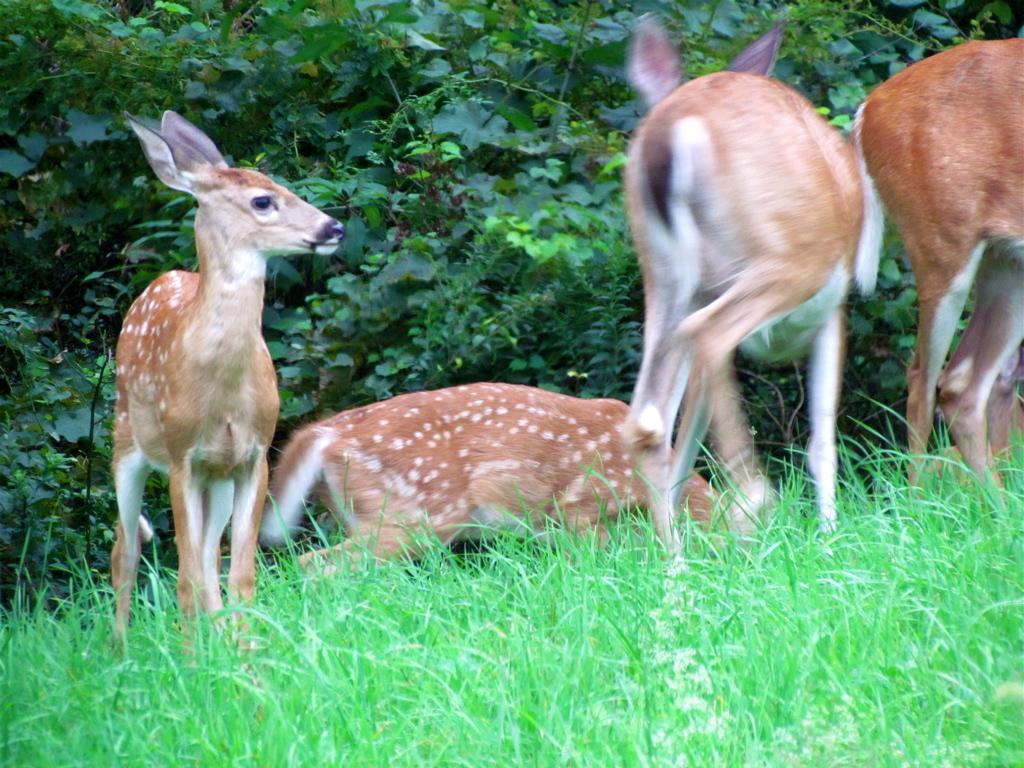Could you give a brief overview of what you see in this image? In the image in the center we can see few deer's,which is in brown and white color. In the background we can see trees and grass. 